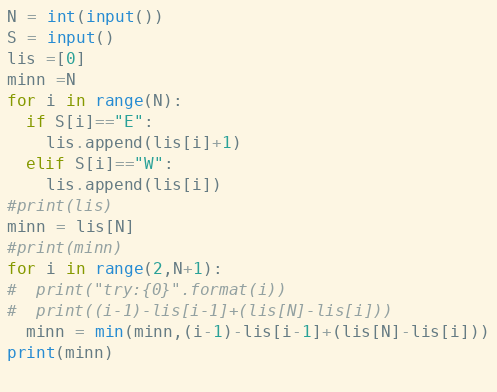<code> <loc_0><loc_0><loc_500><loc_500><_Python_>N = int(input())
S = input()
lis =[0]
minn =N
for i in range(N):
  if S[i]=="E":
    lis.append(lis[i]+1)
  elif S[i]=="W":
    lis.append(lis[i])
#print(lis)
minn = lis[N]
#print(minn)
for i in range(2,N+1):
#  print("try:{0}".format(i))
#  print((i-1)-lis[i-1]+(lis[N]-lis[i]))
  minn = min(minn,(i-1)-lis[i-1]+(lis[N]-lis[i]))
print(minn)
  </code> 